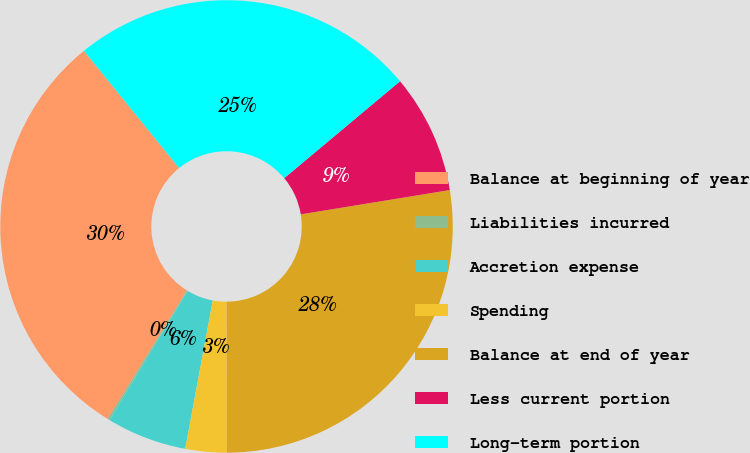Convert chart to OTSL. <chart><loc_0><loc_0><loc_500><loc_500><pie_chart><fcel>Balance at beginning of year<fcel>Liabilities incurred<fcel>Accretion expense<fcel>Spending<fcel>Balance at end of year<fcel>Less current portion<fcel>Long-term portion<nl><fcel>30.34%<fcel>0.15%<fcel>5.73%<fcel>2.94%<fcel>27.55%<fcel>8.52%<fcel>24.76%<nl></chart> 